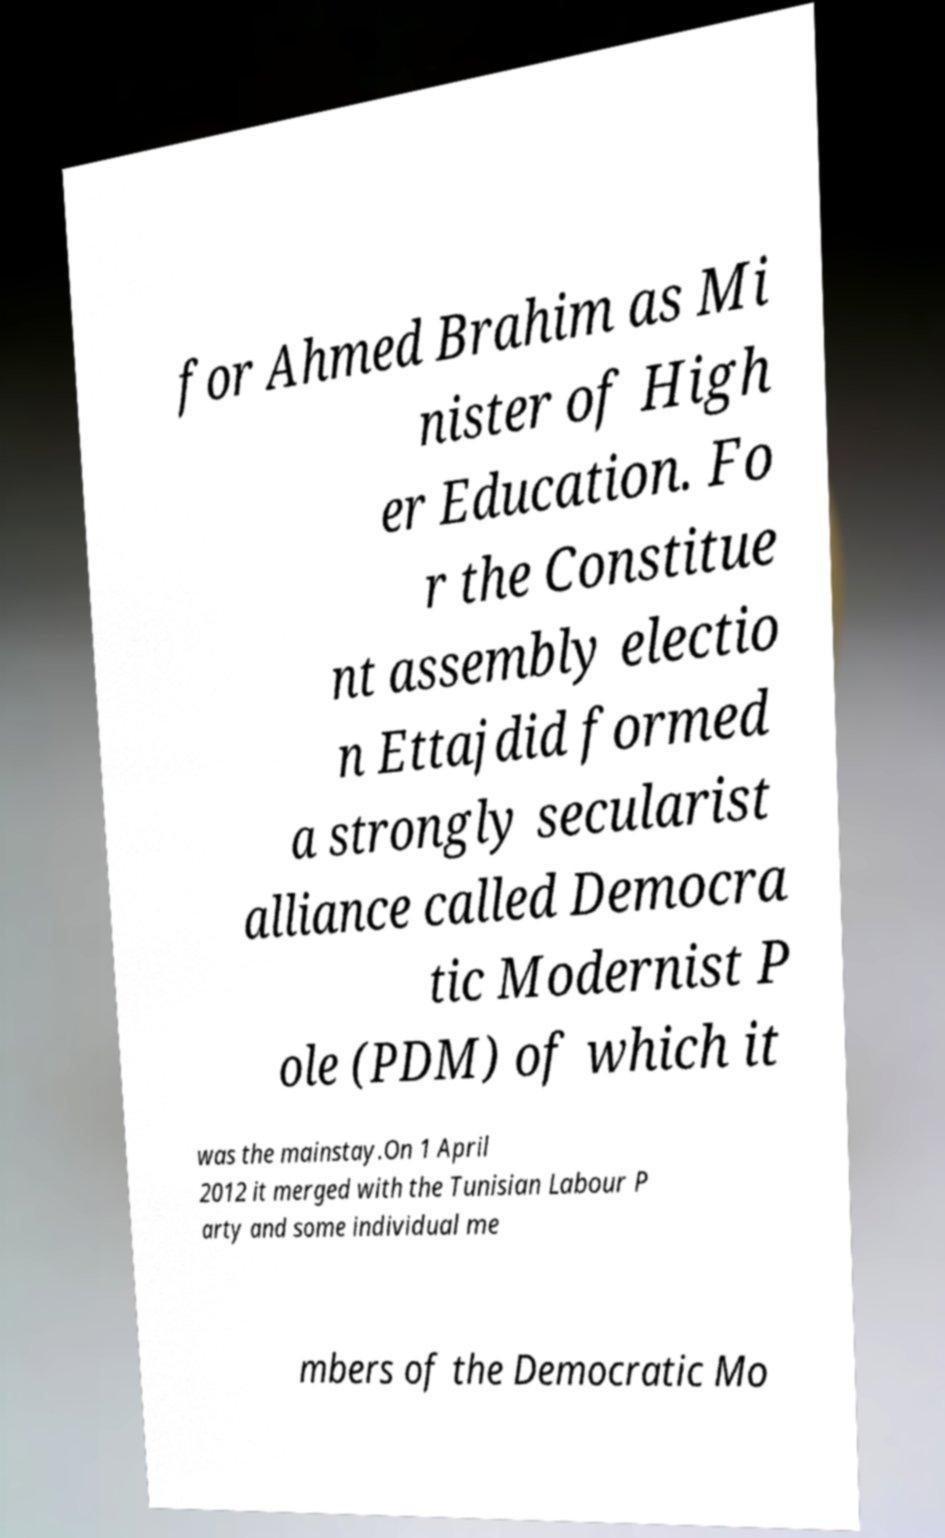Can you read and provide the text displayed in the image?This photo seems to have some interesting text. Can you extract and type it out for me? for Ahmed Brahim as Mi nister of High er Education. Fo r the Constitue nt assembly electio n Ettajdid formed a strongly secularist alliance called Democra tic Modernist P ole (PDM) of which it was the mainstay.On 1 April 2012 it merged with the Tunisian Labour P arty and some individual me mbers of the Democratic Mo 